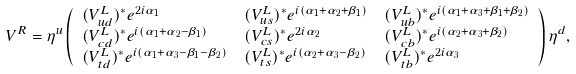Convert formula to latex. <formula><loc_0><loc_0><loc_500><loc_500>V ^ { R } & = \eta ^ { u } \left ( \begin{array} { l l l } ( V ^ { L } _ { u d } ) ^ { * } e ^ { 2 i \alpha _ { 1 } } & ( V ^ { L } _ { u s } ) ^ { * } e ^ { i ( \alpha _ { 1 } + \alpha _ { 2 } + \beta _ { 1 } ) } & ( V ^ { L } _ { u b } ) ^ { * } e ^ { i ( \alpha _ { 1 } + \alpha _ { 3 } + \beta _ { 1 } + \beta _ { 2 } ) } \\ ( V ^ { L } _ { c d } ) ^ { * } e ^ { i ( \alpha _ { 1 } + \alpha _ { 2 } - \beta _ { 1 } ) } & ( V ^ { L } _ { c s } ) ^ { * } e ^ { 2 i \alpha _ { 2 } } & ( V ^ { L } _ { c b } ) ^ { * } e ^ { i ( \alpha _ { 2 } + \alpha _ { 3 } + \beta _ { 2 } ) } \\ ( V ^ { L } _ { t d } ) ^ { * } e ^ { i ( \alpha _ { 1 } + \alpha _ { 3 } - \beta _ { 1 } - \beta _ { 2 } ) } & ( V ^ { L } _ { t s } ) ^ { * } e ^ { i ( \alpha _ { 2 } + \alpha _ { 3 } - \beta _ { 2 } ) } & ( V ^ { L } _ { t b } ) ^ { * } e ^ { 2 i \alpha _ { 3 } } \end{array} \right ) \eta ^ { d } ,</formula> 